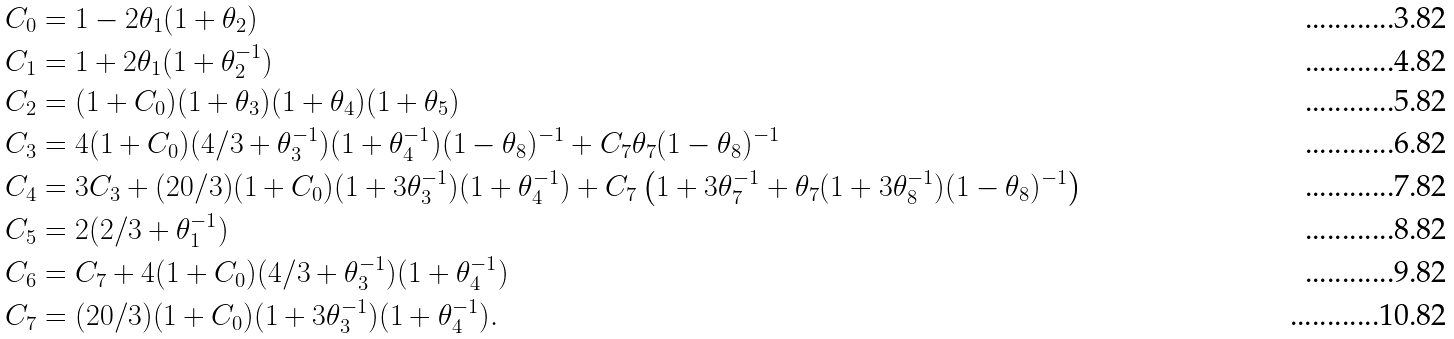<formula> <loc_0><loc_0><loc_500><loc_500>C _ { 0 } & = 1 - 2 \theta _ { 1 } ( 1 + \theta _ { 2 } ) \\ C _ { 1 } & = 1 + 2 \theta _ { 1 } ( 1 + \theta _ { 2 } ^ { - 1 } ) \\ C _ { 2 } & = ( 1 + C _ { 0 } ) ( 1 + \theta _ { 3 } ) ( 1 + \theta _ { 4 } ) ( 1 + \theta _ { 5 } ) \\ C _ { 3 } & = 4 ( 1 + C _ { 0 } ) ( 4 / 3 + \theta _ { 3 } ^ { - 1 } ) ( 1 + \theta _ { 4 } ^ { - 1 } ) ( 1 - \theta _ { 8 } ) ^ { - 1 } + C _ { 7 } \theta _ { 7 } ( 1 - \theta _ { 8 } ) ^ { - 1 } \\ C _ { 4 } & = 3 C _ { 3 } + ( 2 0 / 3 ) ( 1 + C _ { 0 } ) ( 1 + 3 \theta _ { 3 } ^ { - 1 } ) ( 1 + \theta _ { 4 } ^ { - 1 } ) + C _ { 7 } \left ( 1 + 3 \theta _ { 7 } ^ { - 1 } + \theta _ { 7 } ( 1 + 3 \theta _ { 8 } ^ { - 1 } ) ( 1 - \theta _ { 8 } ) ^ { - 1 } \right ) \\ C _ { 5 } & = 2 ( 2 / 3 + \theta _ { 1 } ^ { - 1 } ) \\ C _ { 6 } & = C _ { 7 } + 4 ( 1 + C _ { 0 } ) ( 4 / 3 + \theta _ { 3 } ^ { - 1 } ) ( 1 + \theta _ { 4 } ^ { - 1 } ) \\ C _ { 7 } & = ( 2 0 / 3 ) ( 1 + C _ { 0 } ) ( 1 + 3 \theta _ { 3 } ^ { - 1 } ) ( 1 + \theta _ { 4 } ^ { - 1 } ) .</formula> 